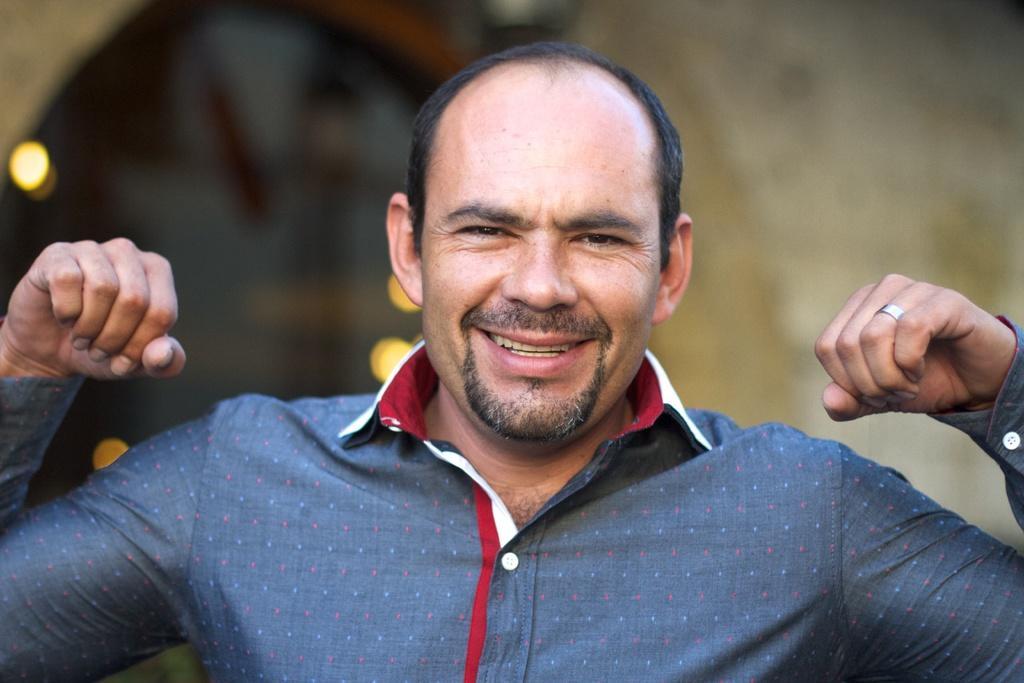How would you summarize this image in a sentence or two? In this picture we can see a person,he is smiling and in the background we can see it is blurry. 